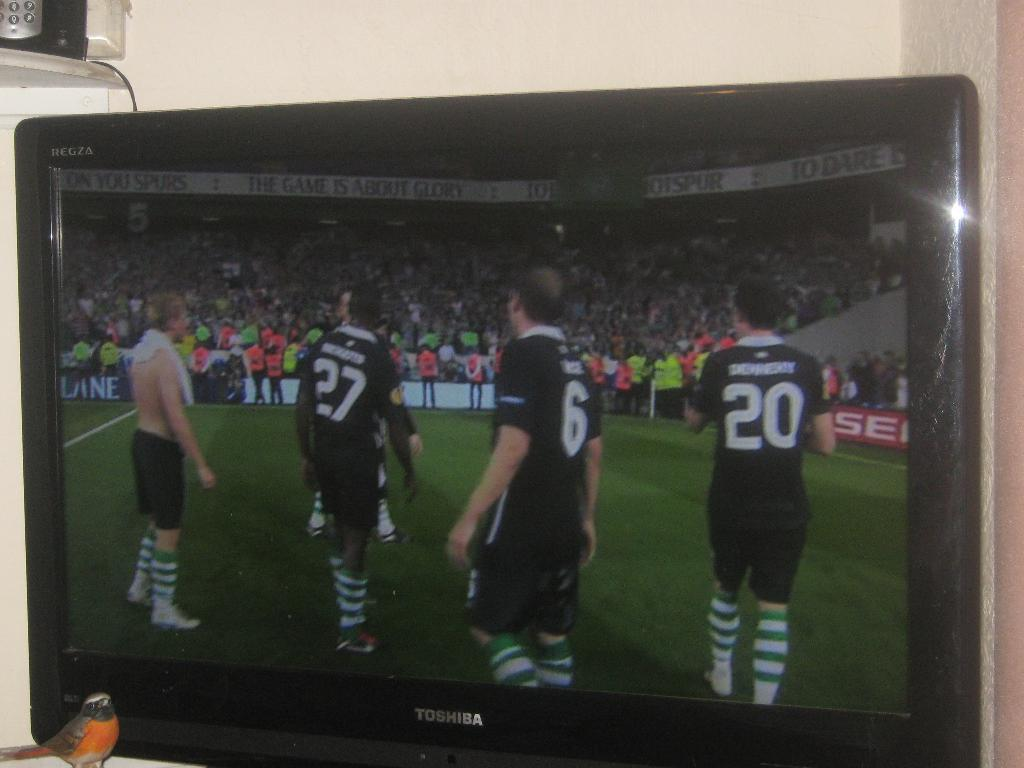<image>
Offer a succinct explanation of the picture presented. On a Toshiba TV screen a group of soccer players are on the playing field.. 